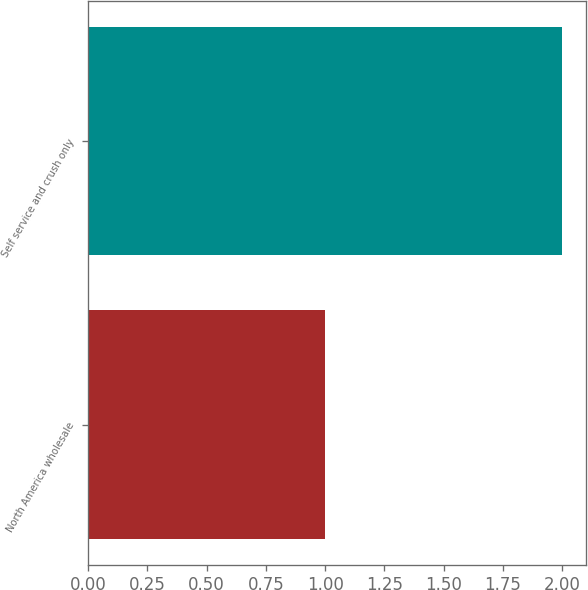Convert chart to OTSL. <chart><loc_0><loc_0><loc_500><loc_500><bar_chart><fcel>North America wholesale<fcel>Self service and crush only<nl><fcel>1<fcel>2<nl></chart> 